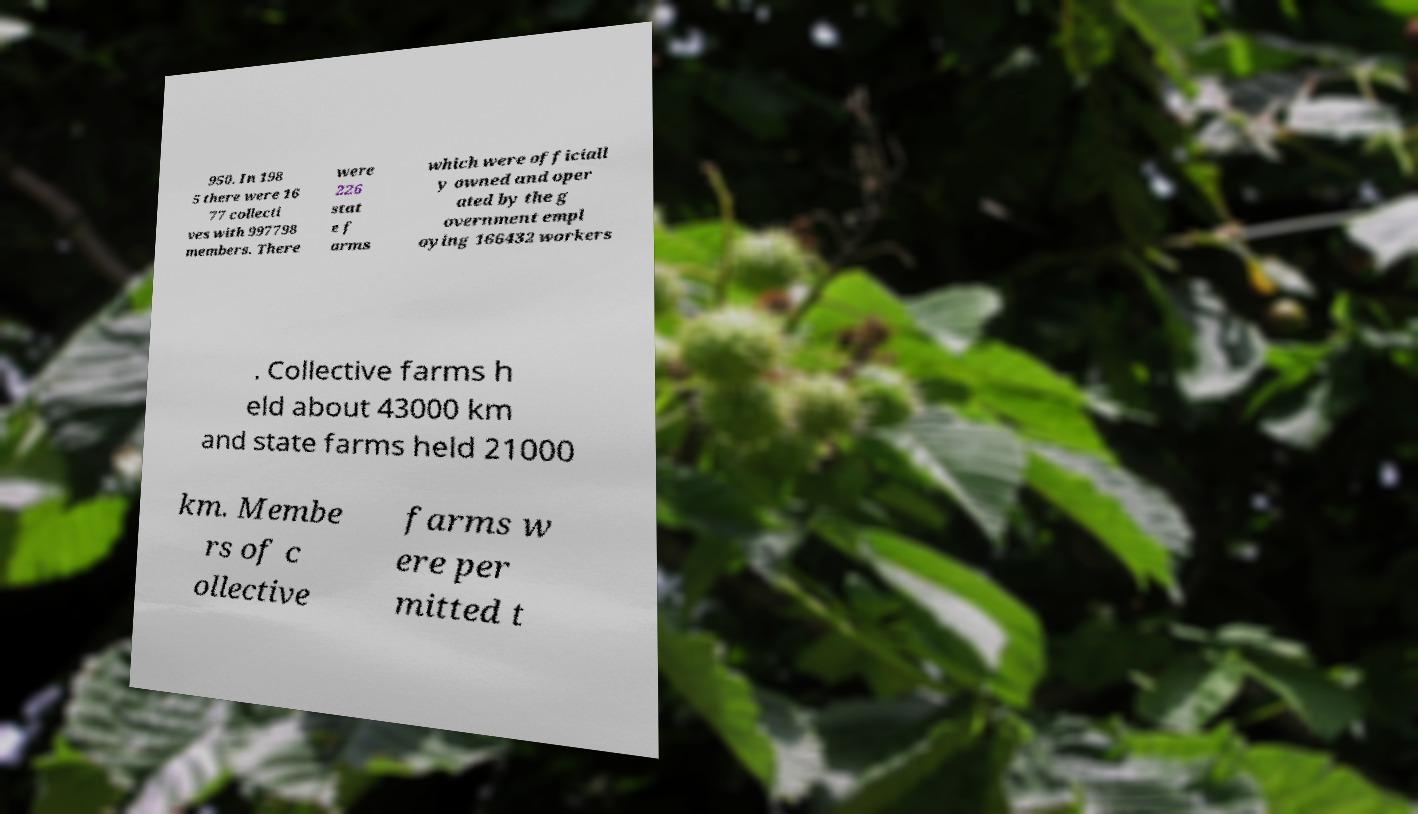Please identify and transcribe the text found in this image. 950. In 198 5 there were 16 77 collecti ves with 997798 members. There were 226 stat e f arms which were officiall y owned and oper ated by the g overnment empl oying 166432 workers . Collective farms h eld about 43000 km and state farms held 21000 km. Membe rs of c ollective farms w ere per mitted t 